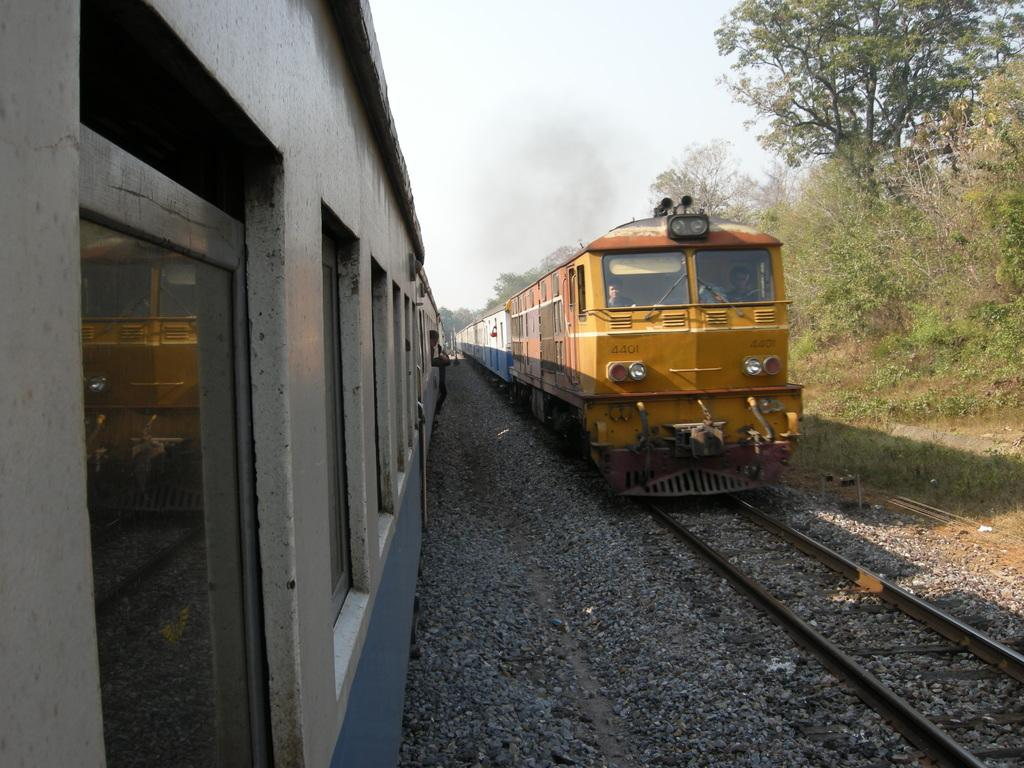What can be seen on the tracks in the image? There are two trains on the tracks in the image. What type of vegetation is present in the image? There are trees and plants in the image. What is visible in the background of the image? The sky is visible in the background of the image. Where is the goat located in the image? There is no goat present in the image. What is the aunt doing in the image? There is no aunt present in the image. 